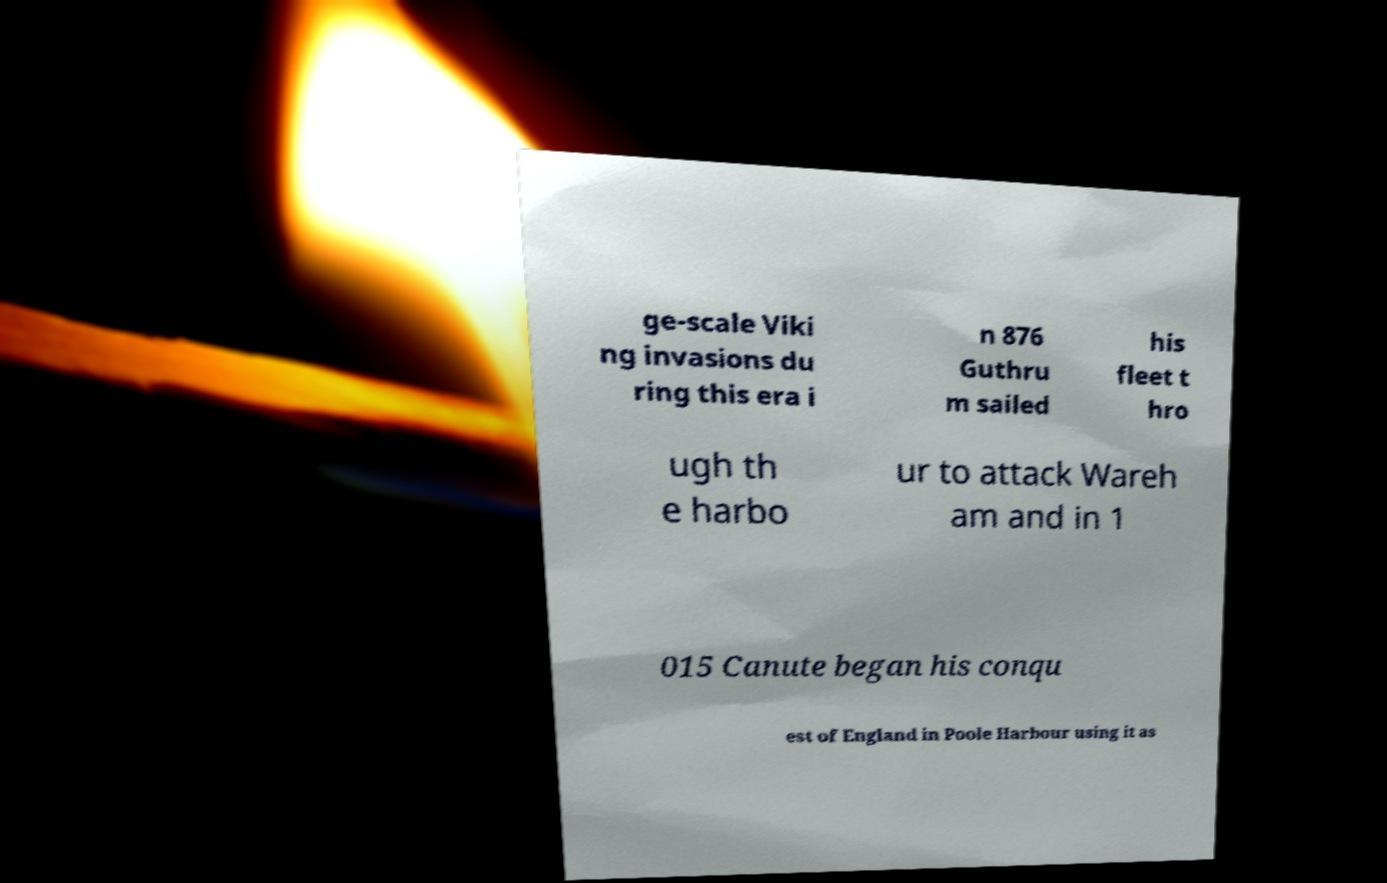Can you accurately transcribe the text from the provided image for me? ge-scale Viki ng invasions du ring this era i n 876 Guthru m sailed his fleet t hro ugh th e harbo ur to attack Wareh am and in 1 015 Canute began his conqu est of England in Poole Harbour using it as 